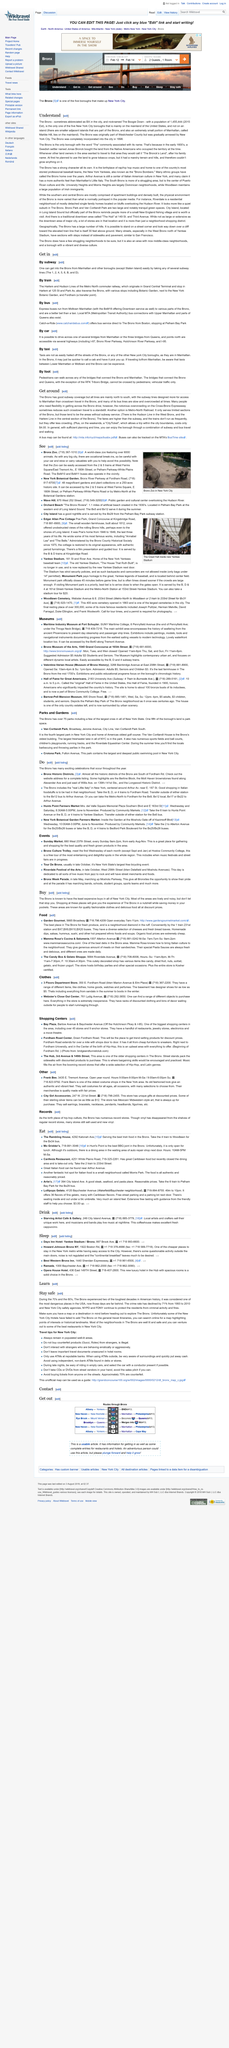Point out several critical features in this image. The Bronx Zoo, which houses over 6000 animals, is a popular destination for wildlife enthusiasts. According to estimates, the population of the Bronx was approximately 1,455,444 in 2015. The Tour De Bronx is the largest free bicycling event in New York State. It is difficult to hail taxis off the streets of the Bronx. The Hub, located at 3rd Avenue and 149th Street in The Bronx, is one of the oldest shopping centers in the borough. 